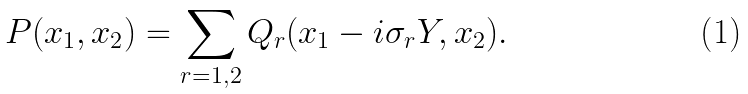Convert formula to latex. <formula><loc_0><loc_0><loc_500><loc_500>P ( x _ { 1 } , x _ { 2 } ) = \sum _ { r = 1 , 2 } Q _ { r } ( x _ { 1 } - i \sigma _ { r } Y , x _ { 2 } ) .</formula> 